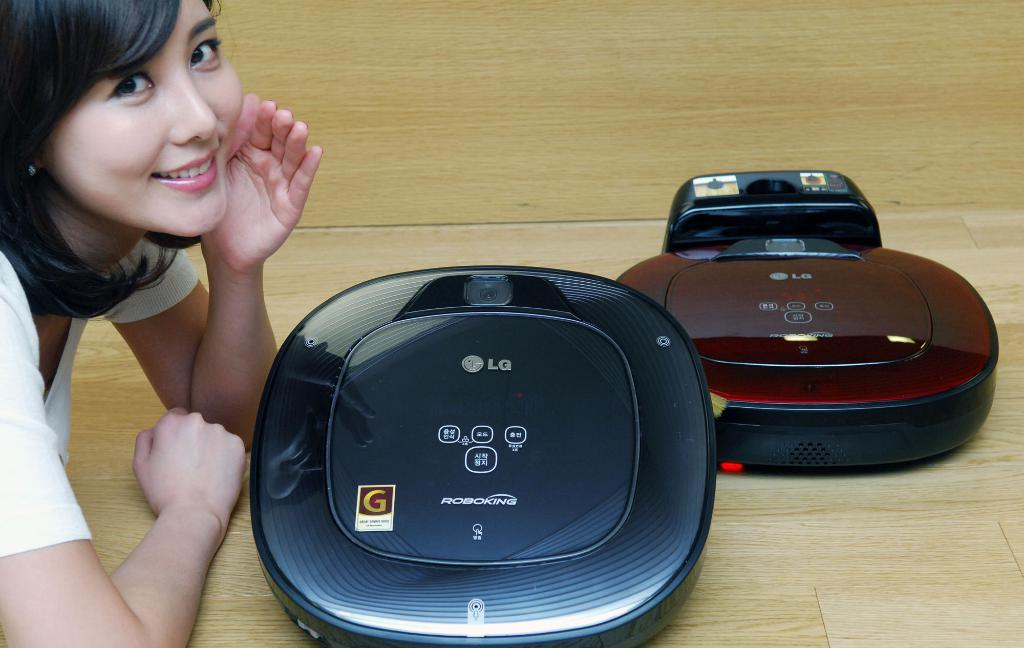<image>
Write a terse but informative summary of the picture. Two LG waffle makers on a table next to a women. 